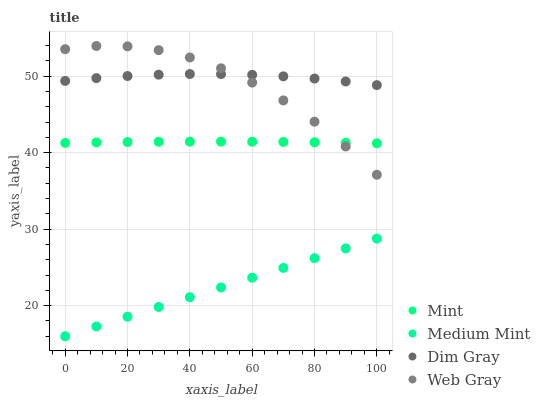Does Medium Mint have the minimum area under the curve?
Answer yes or no. Yes. Does Dim Gray have the maximum area under the curve?
Answer yes or no. Yes. Does Mint have the minimum area under the curve?
Answer yes or no. No. Does Mint have the maximum area under the curve?
Answer yes or no. No. Is Medium Mint the smoothest?
Answer yes or no. Yes. Is Web Gray the roughest?
Answer yes or no. Yes. Is Dim Gray the smoothest?
Answer yes or no. No. Is Dim Gray the roughest?
Answer yes or no. No. Does Medium Mint have the lowest value?
Answer yes or no. Yes. Does Mint have the lowest value?
Answer yes or no. No. Does Web Gray have the highest value?
Answer yes or no. Yes. Does Dim Gray have the highest value?
Answer yes or no. No. Is Medium Mint less than Dim Gray?
Answer yes or no. Yes. Is Dim Gray greater than Mint?
Answer yes or no. Yes. Does Web Gray intersect Mint?
Answer yes or no. Yes. Is Web Gray less than Mint?
Answer yes or no. No. Is Web Gray greater than Mint?
Answer yes or no. No. Does Medium Mint intersect Dim Gray?
Answer yes or no. No. 